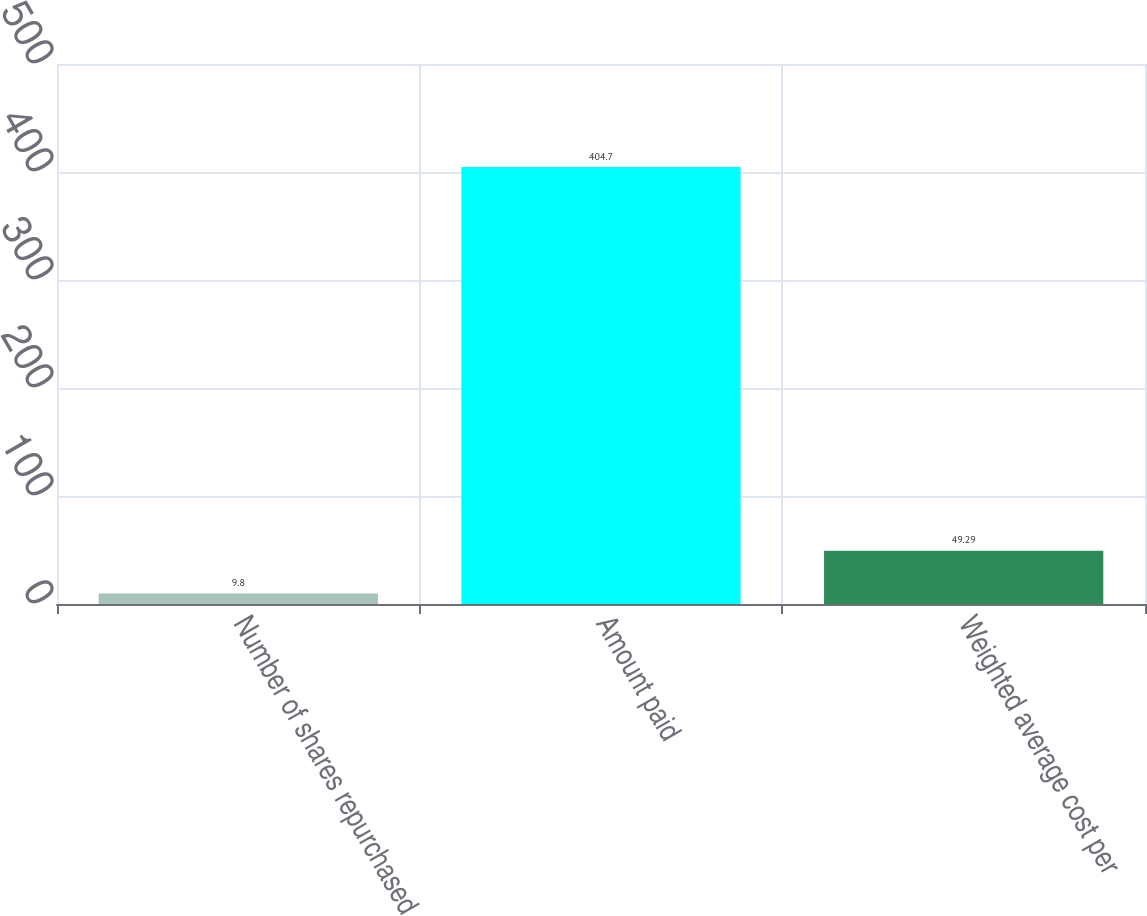Convert chart. <chart><loc_0><loc_0><loc_500><loc_500><bar_chart><fcel>Number of shares repurchased<fcel>Amount paid<fcel>Weighted average cost per<nl><fcel>9.8<fcel>404.7<fcel>49.29<nl></chart> 